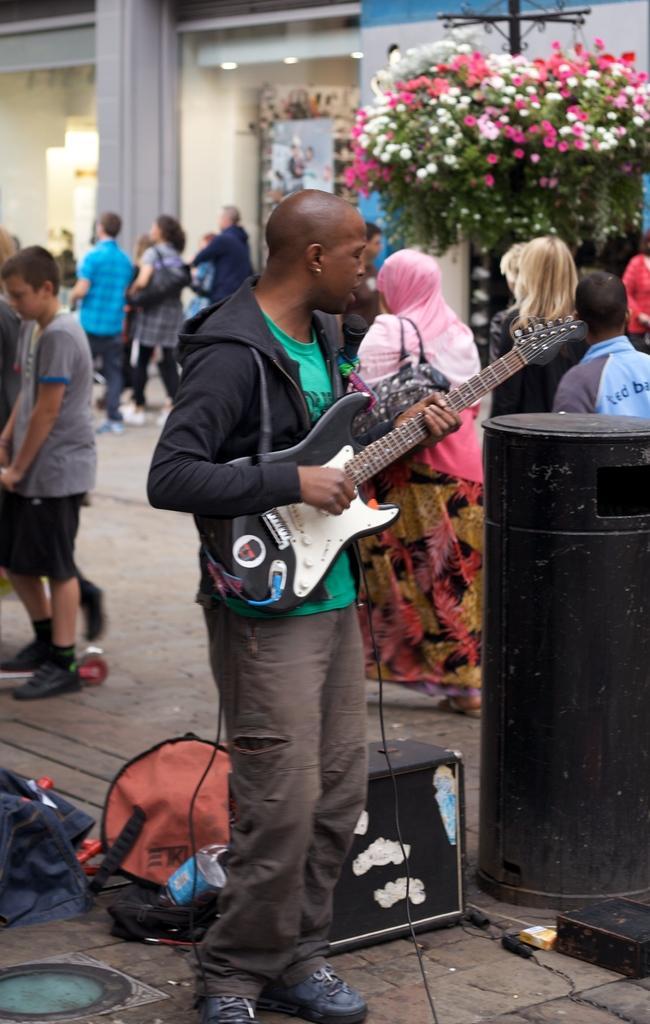Can you describe this image briefly? There are few people on the road walking. In the middle we can see a person playing guitar. In the background we can see a building. Beside the building we see a plant with flowers. 